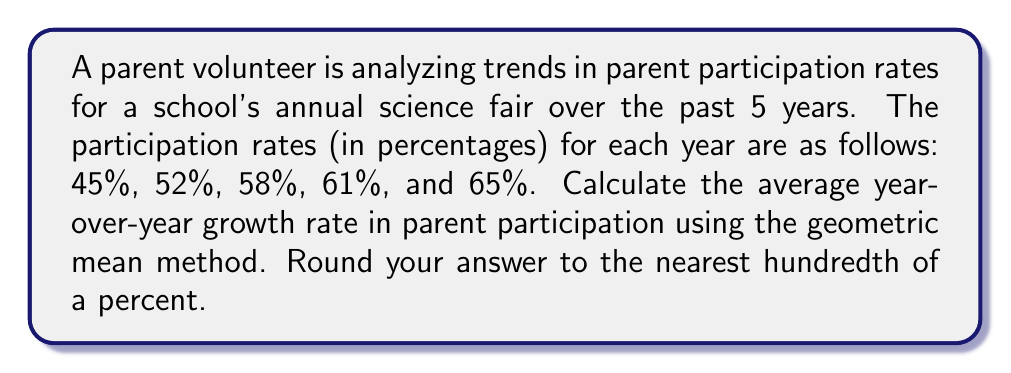Provide a solution to this math problem. To calculate the average year-over-year growth rate using the geometric mean method, we'll follow these steps:

1) First, calculate the year-over-year growth rates:
   Year 1 to 2: $(52\% - 45\%) / 45\% = 15.56\%$
   Year 2 to 3: $(58\% - 52\%) / 52\% = 11.54\%$
   Year 3 to 4: $(61\% - 58\%) / 58\% = 5.17\%$
   Year 4 to 5: $(65\% - 61\%) / 61\% = 6.56\%$

2) Convert these percentages to growth factors by adding 1:
   $1.1556, 1.1154, 1.0517, 1.0656$

3) Calculate the geometric mean of these growth factors:
   $$ \text{Geometric Mean} = \sqrt[4]{1.1556 \times 1.1154 \times 1.0517 \times 1.0656} $$

4) Subtract 1 from the result and multiply by 100 to get the percentage:
   $$ \text{Average Growth Rate} = (\sqrt[4]{1.1556 \times 1.1154 \times 1.0517 \times 1.0656} - 1) \times 100\% $$

5) Calculate:
   $$ \begin{aligned}
   &= (\sqrt[4]{1.4254} - 1) \times 100\% \\
   &= (1.0932 - 1) \times 100\% \\
   &= 0.0932 \times 100\% \\
   &= 9.32\%
   \end{aligned} $$

6) Rounding to the nearest hundredth of a percent: 9.32%
Answer: 9.32% 